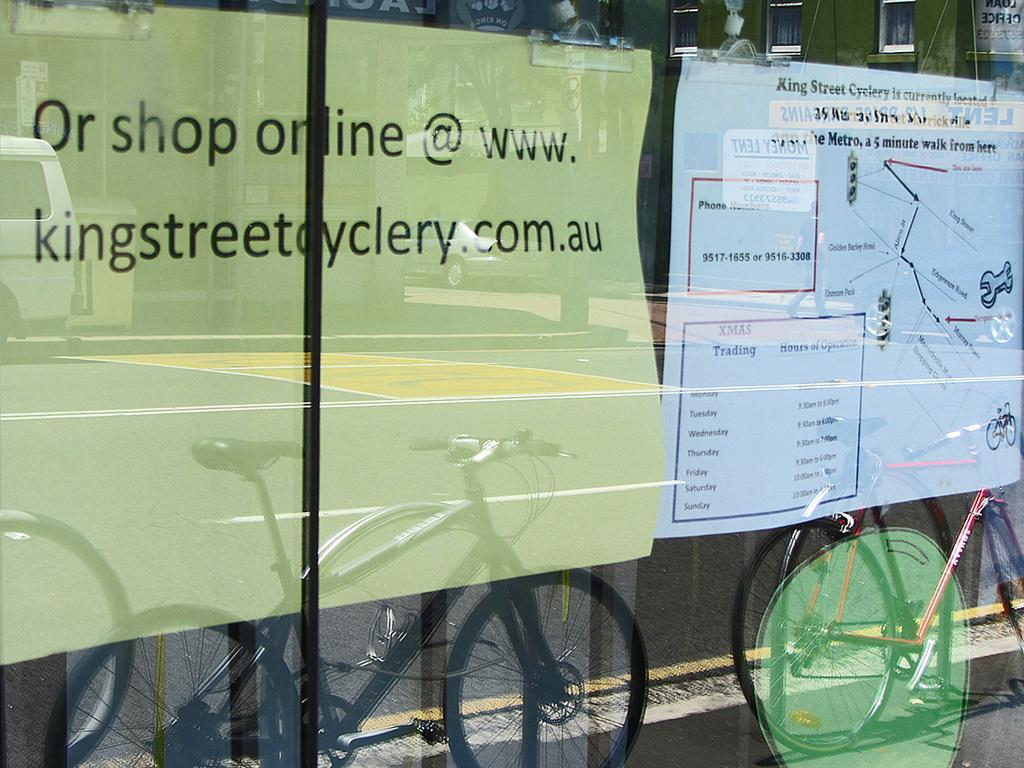What type of wall is present in the image? There is a glass wall in the image. What can be seen through the glass wall? Posters are visible through the glass wall. What types of reflections can be seen on the glass wall? There are reflections of cycles, roads, and vehicles on the glass wall. Are there any other reflections visible on the glass wall? Yes, there are reflections of other objects on the glass wall. What type of advertisement can be seen on the glass wall in the image? There is no advertisement present on the glass wall in the image; it only shows reflections of cycles, roads, vehicles, and other objects. 